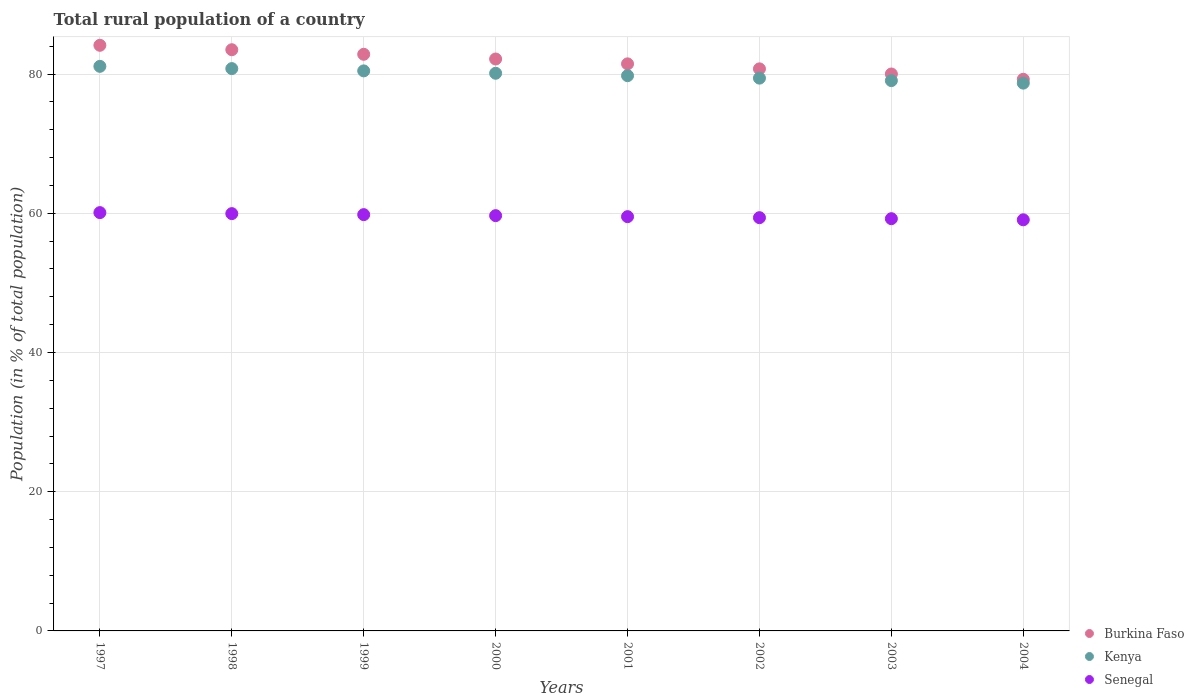How many different coloured dotlines are there?
Your answer should be compact. 3. Is the number of dotlines equal to the number of legend labels?
Provide a succinct answer. Yes. What is the rural population in Senegal in 2000?
Your answer should be compact. 59.66. Across all years, what is the maximum rural population in Burkina Faso?
Ensure brevity in your answer.  84.12. Across all years, what is the minimum rural population in Burkina Faso?
Offer a very short reply. 79.24. In which year was the rural population in Burkina Faso maximum?
Offer a very short reply. 1997. What is the total rural population in Burkina Faso in the graph?
Keep it short and to the point. 654.05. What is the difference between the rural population in Burkina Faso in 1997 and that in 2003?
Make the answer very short. 4.12. What is the difference between the rural population in Kenya in 2002 and the rural population in Senegal in 2000?
Offer a terse response. 19.75. What is the average rural population in Senegal per year?
Make the answer very short. 59.58. In the year 2002, what is the difference between the rural population in Senegal and rural population in Burkina Faso?
Offer a very short reply. -21.38. In how many years, is the rural population in Kenya greater than 20 %?
Provide a succinct answer. 8. What is the ratio of the rural population in Kenya in 1997 to that in 2004?
Offer a very short reply. 1.03. What is the difference between the highest and the second highest rural population in Kenya?
Offer a very short reply. 0.32. What is the difference between the highest and the lowest rural population in Senegal?
Ensure brevity in your answer.  1.03. In how many years, is the rural population in Senegal greater than the average rural population in Senegal taken over all years?
Make the answer very short. 4. Is the sum of the rural population in Kenya in 2000 and 2003 greater than the maximum rural population in Senegal across all years?
Keep it short and to the point. Yes. Is it the case that in every year, the sum of the rural population in Kenya and rural population in Senegal  is greater than the rural population in Burkina Faso?
Offer a terse response. Yes. Is the rural population in Burkina Faso strictly greater than the rural population in Senegal over the years?
Your answer should be very brief. Yes. Is the rural population in Senegal strictly less than the rural population in Kenya over the years?
Keep it short and to the point. Yes. How many years are there in the graph?
Your answer should be very brief. 8. What is the difference between two consecutive major ticks on the Y-axis?
Keep it short and to the point. 20. Does the graph contain any zero values?
Keep it short and to the point. No. How many legend labels are there?
Offer a very short reply. 3. How are the legend labels stacked?
Make the answer very short. Vertical. What is the title of the graph?
Ensure brevity in your answer.  Total rural population of a country. Does "Haiti" appear as one of the legend labels in the graph?
Keep it short and to the point. No. What is the label or title of the Y-axis?
Offer a terse response. Population (in % of total population). What is the Population (in % of total population) of Burkina Faso in 1997?
Give a very brief answer. 84.12. What is the Population (in % of total population) in Kenya in 1997?
Provide a succinct answer. 81.1. What is the Population (in % of total population) in Senegal in 1997?
Keep it short and to the point. 60.09. What is the Population (in % of total population) in Burkina Faso in 1998?
Give a very brief answer. 83.49. What is the Population (in % of total population) of Kenya in 1998?
Your response must be concise. 80.78. What is the Population (in % of total population) of Senegal in 1998?
Keep it short and to the point. 59.95. What is the Population (in % of total population) in Burkina Faso in 1999?
Make the answer very short. 82.83. What is the Population (in % of total population) of Kenya in 1999?
Make the answer very short. 80.45. What is the Population (in % of total population) of Senegal in 1999?
Keep it short and to the point. 59.8. What is the Population (in % of total population) of Burkina Faso in 2000?
Ensure brevity in your answer.  82.16. What is the Population (in % of total population) in Kenya in 2000?
Give a very brief answer. 80.11. What is the Population (in % of total population) of Senegal in 2000?
Give a very brief answer. 59.66. What is the Population (in % of total population) of Burkina Faso in 2001?
Provide a succinct answer. 81.46. What is the Population (in % of total population) of Kenya in 2001?
Your answer should be very brief. 79.76. What is the Population (in % of total population) in Senegal in 2001?
Your answer should be compact. 59.51. What is the Population (in % of total population) in Burkina Faso in 2002?
Keep it short and to the point. 80.74. What is the Population (in % of total population) of Kenya in 2002?
Give a very brief answer. 79.41. What is the Population (in % of total population) in Senegal in 2002?
Your response must be concise. 59.36. What is the Population (in % of total population) of Burkina Faso in 2003?
Keep it short and to the point. 80. What is the Population (in % of total population) in Kenya in 2003?
Your response must be concise. 79.05. What is the Population (in % of total population) in Senegal in 2003?
Your response must be concise. 59.22. What is the Population (in % of total population) of Burkina Faso in 2004?
Your response must be concise. 79.24. What is the Population (in % of total population) of Kenya in 2004?
Provide a succinct answer. 78.69. What is the Population (in % of total population) in Senegal in 2004?
Your answer should be compact. 59.06. Across all years, what is the maximum Population (in % of total population) in Burkina Faso?
Ensure brevity in your answer.  84.12. Across all years, what is the maximum Population (in % of total population) in Kenya?
Ensure brevity in your answer.  81.1. Across all years, what is the maximum Population (in % of total population) in Senegal?
Make the answer very short. 60.09. Across all years, what is the minimum Population (in % of total population) of Burkina Faso?
Ensure brevity in your answer.  79.24. Across all years, what is the minimum Population (in % of total population) in Kenya?
Make the answer very short. 78.69. Across all years, what is the minimum Population (in % of total population) in Senegal?
Offer a very short reply. 59.06. What is the total Population (in % of total population) of Burkina Faso in the graph?
Your answer should be compact. 654.05. What is the total Population (in % of total population) in Kenya in the graph?
Ensure brevity in your answer.  639.35. What is the total Population (in % of total population) of Senegal in the graph?
Your answer should be very brief. 476.64. What is the difference between the Population (in % of total population) in Burkina Faso in 1997 and that in 1998?
Provide a succinct answer. 0.64. What is the difference between the Population (in % of total population) of Kenya in 1997 and that in 1998?
Give a very brief answer. 0.32. What is the difference between the Population (in % of total population) of Senegal in 1997 and that in 1998?
Offer a very short reply. 0.14. What is the difference between the Population (in % of total population) of Burkina Faso in 1997 and that in 1999?
Your answer should be very brief. 1.29. What is the difference between the Population (in % of total population) in Kenya in 1997 and that in 1999?
Your answer should be very brief. 0.65. What is the difference between the Population (in % of total population) in Senegal in 1997 and that in 1999?
Provide a succinct answer. 0.29. What is the difference between the Population (in % of total population) of Burkina Faso in 1997 and that in 2000?
Your answer should be compact. 1.97. What is the difference between the Population (in % of total population) in Senegal in 1997 and that in 2000?
Make the answer very short. 0.43. What is the difference between the Population (in % of total population) of Burkina Faso in 1997 and that in 2001?
Offer a very short reply. 2.67. What is the difference between the Population (in % of total population) of Kenya in 1997 and that in 2001?
Give a very brief answer. 1.34. What is the difference between the Population (in % of total population) in Senegal in 1997 and that in 2001?
Ensure brevity in your answer.  0.58. What is the difference between the Population (in % of total population) of Burkina Faso in 1997 and that in 2002?
Your answer should be compact. 3.38. What is the difference between the Population (in % of total population) of Kenya in 1997 and that in 2002?
Offer a terse response. 1.69. What is the difference between the Population (in % of total population) of Senegal in 1997 and that in 2002?
Make the answer very short. 0.73. What is the difference between the Population (in % of total population) in Burkina Faso in 1997 and that in 2003?
Make the answer very short. 4.12. What is the difference between the Population (in % of total population) in Kenya in 1997 and that in 2003?
Keep it short and to the point. 2.05. What is the difference between the Population (in % of total population) in Senegal in 1997 and that in 2003?
Ensure brevity in your answer.  0.87. What is the difference between the Population (in % of total population) in Burkina Faso in 1997 and that in 2004?
Offer a terse response. 4.88. What is the difference between the Population (in % of total population) in Kenya in 1997 and that in 2004?
Ensure brevity in your answer.  2.41. What is the difference between the Population (in % of total population) of Senegal in 1997 and that in 2004?
Your response must be concise. 1.03. What is the difference between the Population (in % of total population) of Burkina Faso in 1998 and that in 1999?
Your response must be concise. 0.66. What is the difference between the Population (in % of total population) of Kenya in 1998 and that in 1999?
Ensure brevity in your answer.  0.33. What is the difference between the Population (in % of total population) of Senegal in 1998 and that in 1999?
Give a very brief answer. 0.14. What is the difference between the Population (in % of total population) of Burkina Faso in 1998 and that in 2000?
Your answer should be compact. 1.33. What is the difference between the Population (in % of total population) in Kenya in 1998 and that in 2000?
Offer a terse response. 0.67. What is the difference between the Population (in % of total population) of Senegal in 1998 and that in 2000?
Your answer should be very brief. 0.29. What is the difference between the Population (in % of total population) of Burkina Faso in 1998 and that in 2001?
Offer a terse response. 2.03. What is the difference between the Population (in % of total population) in Senegal in 1998 and that in 2001?
Keep it short and to the point. 0.43. What is the difference between the Population (in % of total population) in Burkina Faso in 1998 and that in 2002?
Your response must be concise. 2.75. What is the difference between the Population (in % of total population) of Kenya in 1998 and that in 2002?
Keep it short and to the point. 1.37. What is the difference between the Population (in % of total population) of Senegal in 1998 and that in 2002?
Make the answer very short. 0.58. What is the difference between the Population (in % of total population) of Burkina Faso in 1998 and that in 2003?
Your answer should be compact. 3.49. What is the difference between the Population (in % of total population) of Kenya in 1998 and that in 2003?
Your answer should be very brief. 1.73. What is the difference between the Population (in % of total population) of Senegal in 1998 and that in 2003?
Provide a succinct answer. 0.73. What is the difference between the Population (in % of total population) in Burkina Faso in 1998 and that in 2004?
Give a very brief answer. 4.25. What is the difference between the Population (in % of total population) in Kenya in 1998 and that in 2004?
Your answer should be compact. 2.09. What is the difference between the Population (in % of total population) of Senegal in 1998 and that in 2004?
Provide a short and direct response. 0.89. What is the difference between the Population (in % of total population) in Burkina Faso in 1999 and that in 2000?
Ensure brevity in your answer.  0.68. What is the difference between the Population (in % of total population) in Kenya in 1999 and that in 2000?
Your answer should be very brief. 0.34. What is the difference between the Population (in % of total population) of Senegal in 1999 and that in 2000?
Your response must be concise. 0.14. What is the difference between the Population (in % of total population) in Burkina Faso in 1999 and that in 2001?
Keep it short and to the point. 1.37. What is the difference between the Population (in % of total population) of Kenya in 1999 and that in 2001?
Your answer should be compact. 0.69. What is the difference between the Population (in % of total population) of Senegal in 1999 and that in 2001?
Your answer should be compact. 0.29. What is the difference between the Population (in % of total population) in Burkina Faso in 1999 and that in 2002?
Give a very brief answer. 2.09. What is the difference between the Population (in % of total population) of Kenya in 1999 and that in 2002?
Your answer should be very brief. 1.04. What is the difference between the Population (in % of total population) in Senegal in 1999 and that in 2002?
Give a very brief answer. 0.44. What is the difference between the Population (in % of total population) in Burkina Faso in 1999 and that in 2003?
Provide a succinct answer. 2.83. What is the difference between the Population (in % of total population) of Kenya in 1999 and that in 2003?
Offer a terse response. 1.4. What is the difference between the Population (in % of total population) in Senegal in 1999 and that in 2003?
Keep it short and to the point. 0.58. What is the difference between the Population (in % of total population) in Burkina Faso in 1999 and that in 2004?
Make the answer very short. 3.59. What is the difference between the Population (in % of total population) in Kenya in 1999 and that in 2004?
Offer a terse response. 1.76. What is the difference between the Population (in % of total population) in Senegal in 1999 and that in 2004?
Provide a succinct answer. 0.74. What is the difference between the Population (in % of total population) of Burkina Faso in 2000 and that in 2001?
Your answer should be compact. 0.7. What is the difference between the Population (in % of total population) of Kenya in 2000 and that in 2001?
Ensure brevity in your answer.  0.35. What is the difference between the Population (in % of total population) of Senegal in 2000 and that in 2001?
Offer a terse response. 0.14. What is the difference between the Population (in % of total population) in Burkina Faso in 2000 and that in 2002?
Provide a succinct answer. 1.41. What is the difference between the Population (in % of total population) in Kenya in 2000 and that in 2002?
Keep it short and to the point. 0.7. What is the difference between the Population (in % of total population) of Senegal in 2000 and that in 2002?
Ensure brevity in your answer.  0.29. What is the difference between the Population (in % of total population) of Burkina Faso in 2000 and that in 2003?
Provide a succinct answer. 2.15. What is the difference between the Population (in % of total population) of Kenya in 2000 and that in 2003?
Give a very brief answer. 1.06. What is the difference between the Population (in % of total population) of Senegal in 2000 and that in 2003?
Make the answer very short. 0.44. What is the difference between the Population (in % of total population) in Burkina Faso in 2000 and that in 2004?
Your response must be concise. 2.91. What is the difference between the Population (in % of total population) of Kenya in 2000 and that in 2004?
Offer a terse response. 1.42. What is the difference between the Population (in % of total population) of Senegal in 2000 and that in 2004?
Ensure brevity in your answer.  0.6. What is the difference between the Population (in % of total population) in Burkina Faso in 2001 and that in 2002?
Your answer should be very brief. 0.72. What is the difference between the Population (in % of total population) of Kenya in 2001 and that in 2002?
Offer a terse response. 0.35. What is the difference between the Population (in % of total population) in Senegal in 2001 and that in 2002?
Offer a very short reply. 0.15. What is the difference between the Population (in % of total population) of Burkina Faso in 2001 and that in 2003?
Make the answer very short. 1.46. What is the difference between the Population (in % of total population) of Kenya in 2001 and that in 2003?
Ensure brevity in your answer.  0.71. What is the difference between the Population (in % of total population) of Senegal in 2001 and that in 2003?
Offer a terse response. 0.29. What is the difference between the Population (in % of total population) of Burkina Faso in 2001 and that in 2004?
Provide a succinct answer. 2.22. What is the difference between the Population (in % of total population) of Kenya in 2001 and that in 2004?
Your answer should be compact. 1.07. What is the difference between the Population (in % of total population) in Senegal in 2001 and that in 2004?
Provide a short and direct response. 0.45. What is the difference between the Population (in % of total population) in Burkina Faso in 2002 and that in 2003?
Give a very brief answer. 0.74. What is the difference between the Population (in % of total population) in Kenya in 2002 and that in 2003?
Your response must be concise. 0.36. What is the difference between the Population (in % of total population) in Senegal in 2002 and that in 2003?
Your answer should be very brief. 0.15. What is the difference between the Population (in % of total population) in Burkina Faso in 2002 and that in 2004?
Your answer should be very brief. 1.5. What is the difference between the Population (in % of total population) of Kenya in 2002 and that in 2004?
Your response must be concise. 0.72. What is the difference between the Population (in % of total population) of Senegal in 2002 and that in 2004?
Give a very brief answer. 0.31. What is the difference between the Population (in % of total population) of Burkina Faso in 2003 and that in 2004?
Your response must be concise. 0.76. What is the difference between the Population (in % of total population) of Kenya in 2003 and that in 2004?
Offer a terse response. 0.36. What is the difference between the Population (in % of total population) of Senegal in 2003 and that in 2004?
Your answer should be compact. 0.16. What is the difference between the Population (in % of total population) in Burkina Faso in 1997 and the Population (in % of total population) in Kenya in 1998?
Offer a very short reply. 3.35. What is the difference between the Population (in % of total population) in Burkina Faso in 1997 and the Population (in % of total population) in Senegal in 1998?
Give a very brief answer. 24.18. What is the difference between the Population (in % of total population) in Kenya in 1997 and the Population (in % of total population) in Senegal in 1998?
Ensure brevity in your answer.  21.16. What is the difference between the Population (in % of total population) of Burkina Faso in 1997 and the Population (in % of total population) of Kenya in 1999?
Give a very brief answer. 3.67. What is the difference between the Population (in % of total population) of Burkina Faso in 1997 and the Population (in % of total population) of Senegal in 1999?
Offer a terse response. 24.32. What is the difference between the Population (in % of total population) in Kenya in 1997 and the Population (in % of total population) in Senegal in 1999?
Offer a terse response. 21.3. What is the difference between the Population (in % of total population) in Burkina Faso in 1997 and the Population (in % of total population) in Kenya in 2000?
Provide a succinct answer. 4.02. What is the difference between the Population (in % of total population) of Burkina Faso in 1997 and the Population (in % of total population) of Senegal in 2000?
Your response must be concise. 24.47. What is the difference between the Population (in % of total population) of Kenya in 1997 and the Population (in % of total population) of Senegal in 2000?
Ensure brevity in your answer.  21.45. What is the difference between the Population (in % of total population) in Burkina Faso in 1997 and the Population (in % of total population) in Kenya in 2001?
Give a very brief answer. 4.36. What is the difference between the Population (in % of total population) of Burkina Faso in 1997 and the Population (in % of total population) of Senegal in 2001?
Your response must be concise. 24.61. What is the difference between the Population (in % of total population) of Kenya in 1997 and the Population (in % of total population) of Senegal in 2001?
Your response must be concise. 21.59. What is the difference between the Population (in % of total population) in Burkina Faso in 1997 and the Population (in % of total population) in Kenya in 2002?
Your answer should be compact. 4.72. What is the difference between the Population (in % of total population) of Burkina Faso in 1997 and the Population (in % of total population) of Senegal in 2002?
Your answer should be compact. 24.76. What is the difference between the Population (in % of total population) of Kenya in 1997 and the Population (in % of total population) of Senegal in 2002?
Your answer should be compact. 21.74. What is the difference between the Population (in % of total population) of Burkina Faso in 1997 and the Population (in % of total population) of Kenya in 2003?
Make the answer very short. 5.07. What is the difference between the Population (in % of total population) in Burkina Faso in 1997 and the Population (in % of total population) in Senegal in 2003?
Your answer should be very brief. 24.91. What is the difference between the Population (in % of total population) of Kenya in 1997 and the Population (in % of total population) of Senegal in 2003?
Provide a short and direct response. 21.88. What is the difference between the Population (in % of total population) in Burkina Faso in 1997 and the Population (in % of total population) in Kenya in 2004?
Ensure brevity in your answer.  5.43. What is the difference between the Population (in % of total population) in Burkina Faso in 1997 and the Population (in % of total population) in Senegal in 2004?
Provide a short and direct response. 25.07. What is the difference between the Population (in % of total population) in Kenya in 1997 and the Population (in % of total population) in Senegal in 2004?
Your response must be concise. 22.05. What is the difference between the Population (in % of total population) of Burkina Faso in 1998 and the Population (in % of total population) of Kenya in 1999?
Keep it short and to the point. 3.04. What is the difference between the Population (in % of total population) in Burkina Faso in 1998 and the Population (in % of total population) in Senegal in 1999?
Provide a succinct answer. 23.69. What is the difference between the Population (in % of total population) in Kenya in 1998 and the Population (in % of total population) in Senegal in 1999?
Make the answer very short. 20.98. What is the difference between the Population (in % of total population) in Burkina Faso in 1998 and the Population (in % of total population) in Kenya in 2000?
Your answer should be very brief. 3.38. What is the difference between the Population (in % of total population) of Burkina Faso in 1998 and the Population (in % of total population) of Senegal in 2000?
Your response must be concise. 23.84. What is the difference between the Population (in % of total population) of Kenya in 1998 and the Population (in % of total population) of Senegal in 2000?
Keep it short and to the point. 21.12. What is the difference between the Population (in % of total population) in Burkina Faso in 1998 and the Population (in % of total population) in Kenya in 2001?
Your answer should be compact. 3.73. What is the difference between the Population (in % of total population) in Burkina Faso in 1998 and the Population (in % of total population) in Senegal in 2001?
Keep it short and to the point. 23.98. What is the difference between the Population (in % of total population) in Kenya in 1998 and the Population (in % of total population) in Senegal in 2001?
Make the answer very short. 21.27. What is the difference between the Population (in % of total population) in Burkina Faso in 1998 and the Population (in % of total population) in Kenya in 2002?
Ensure brevity in your answer.  4.08. What is the difference between the Population (in % of total population) of Burkina Faso in 1998 and the Population (in % of total population) of Senegal in 2002?
Your answer should be compact. 24.13. What is the difference between the Population (in % of total population) of Kenya in 1998 and the Population (in % of total population) of Senegal in 2002?
Your answer should be very brief. 21.41. What is the difference between the Population (in % of total population) in Burkina Faso in 1998 and the Population (in % of total population) in Kenya in 2003?
Offer a terse response. 4.44. What is the difference between the Population (in % of total population) in Burkina Faso in 1998 and the Population (in % of total population) in Senegal in 2003?
Provide a short and direct response. 24.27. What is the difference between the Population (in % of total population) in Kenya in 1998 and the Population (in % of total population) in Senegal in 2003?
Offer a very short reply. 21.56. What is the difference between the Population (in % of total population) of Burkina Faso in 1998 and the Population (in % of total population) of Senegal in 2004?
Keep it short and to the point. 24.43. What is the difference between the Population (in % of total population) of Kenya in 1998 and the Population (in % of total population) of Senegal in 2004?
Keep it short and to the point. 21.72. What is the difference between the Population (in % of total population) in Burkina Faso in 1999 and the Population (in % of total population) in Kenya in 2000?
Ensure brevity in your answer.  2.73. What is the difference between the Population (in % of total population) in Burkina Faso in 1999 and the Population (in % of total population) in Senegal in 2000?
Offer a very short reply. 23.18. What is the difference between the Population (in % of total population) of Kenya in 1999 and the Population (in % of total population) of Senegal in 2000?
Provide a short and direct response. 20.8. What is the difference between the Population (in % of total population) of Burkina Faso in 1999 and the Population (in % of total population) of Kenya in 2001?
Make the answer very short. 3.07. What is the difference between the Population (in % of total population) of Burkina Faso in 1999 and the Population (in % of total population) of Senegal in 2001?
Provide a short and direct response. 23.32. What is the difference between the Population (in % of total population) of Kenya in 1999 and the Population (in % of total population) of Senegal in 2001?
Give a very brief answer. 20.94. What is the difference between the Population (in % of total population) in Burkina Faso in 1999 and the Population (in % of total population) in Kenya in 2002?
Your response must be concise. 3.42. What is the difference between the Population (in % of total population) in Burkina Faso in 1999 and the Population (in % of total population) in Senegal in 2002?
Your answer should be compact. 23.47. What is the difference between the Population (in % of total population) in Kenya in 1999 and the Population (in % of total population) in Senegal in 2002?
Your answer should be compact. 21.09. What is the difference between the Population (in % of total population) of Burkina Faso in 1999 and the Population (in % of total population) of Kenya in 2003?
Keep it short and to the point. 3.78. What is the difference between the Population (in % of total population) of Burkina Faso in 1999 and the Population (in % of total population) of Senegal in 2003?
Give a very brief answer. 23.62. What is the difference between the Population (in % of total population) of Kenya in 1999 and the Population (in % of total population) of Senegal in 2003?
Your answer should be compact. 21.23. What is the difference between the Population (in % of total population) in Burkina Faso in 1999 and the Population (in % of total population) in Kenya in 2004?
Make the answer very short. 4.14. What is the difference between the Population (in % of total population) of Burkina Faso in 1999 and the Population (in % of total population) of Senegal in 2004?
Give a very brief answer. 23.78. What is the difference between the Population (in % of total population) of Kenya in 1999 and the Population (in % of total population) of Senegal in 2004?
Provide a short and direct response. 21.39. What is the difference between the Population (in % of total population) in Burkina Faso in 2000 and the Population (in % of total population) in Kenya in 2001?
Provide a short and direct response. 2.4. What is the difference between the Population (in % of total population) of Burkina Faso in 2000 and the Population (in % of total population) of Senegal in 2001?
Provide a short and direct response. 22.65. What is the difference between the Population (in % of total population) of Kenya in 2000 and the Population (in % of total population) of Senegal in 2001?
Ensure brevity in your answer.  20.6. What is the difference between the Population (in % of total population) of Burkina Faso in 2000 and the Population (in % of total population) of Kenya in 2002?
Offer a very short reply. 2.75. What is the difference between the Population (in % of total population) in Burkina Faso in 2000 and the Population (in % of total population) in Senegal in 2002?
Provide a succinct answer. 22.79. What is the difference between the Population (in % of total population) of Kenya in 2000 and the Population (in % of total population) of Senegal in 2002?
Provide a succinct answer. 20.74. What is the difference between the Population (in % of total population) in Burkina Faso in 2000 and the Population (in % of total population) in Kenya in 2003?
Ensure brevity in your answer.  3.1. What is the difference between the Population (in % of total population) in Burkina Faso in 2000 and the Population (in % of total population) in Senegal in 2003?
Offer a very short reply. 22.94. What is the difference between the Population (in % of total population) in Kenya in 2000 and the Population (in % of total population) in Senegal in 2003?
Provide a succinct answer. 20.89. What is the difference between the Population (in % of total population) of Burkina Faso in 2000 and the Population (in % of total population) of Kenya in 2004?
Your response must be concise. 3.47. What is the difference between the Population (in % of total population) of Burkina Faso in 2000 and the Population (in % of total population) of Senegal in 2004?
Give a very brief answer. 23.1. What is the difference between the Population (in % of total population) of Kenya in 2000 and the Population (in % of total population) of Senegal in 2004?
Your answer should be very brief. 21.05. What is the difference between the Population (in % of total population) in Burkina Faso in 2001 and the Population (in % of total population) in Kenya in 2002?
Give a very brief answer. 2.05. What is the difference between the Population (in % of total population) of Burkina Faso in 2001 and the Population (in % of total population) of Senegal in 2002?
Give a very brief answer. 22.1. What is the difference between the Population (in % of total population) of Kenya in 2001 and the Population (in % of total population) of Senegal in 2002?
Your response must be concise. 20.4. What is the difference between the Population (in % of total population) in Burkina Faso in 2001 and the Population (in % of total population) in Kenya in 2003?
Your answer should be very brief. 2.41. What is the difference between the Population (in % of total population) of Burkina Faso in 2001 and the Population (in % of total population) of Senegal in 2003?
Give a very brief answer. 22.24. What is the difference between the Population (in % of total population) of Kenya in 2001 and the Population (in % of total population) of Senegal in 2003?
Provide a short and direct response. 20.54. What is the difference between the Population (in % of total population) of Burkina Faso in 2001 and the Population (in % of total population) of Kenya in 2004?
Ensure brevity in your answer.  2.77. What is the difference between the Population (in % of total population) of Burkina Faso in 2001 and the Population (in % of total population) of Senegal in 2004?
Give a very brief answer. 22.4. What is the difference between the Population (in % of total population) in Kenya in 2001 and the Population (in % of total population) in Senegal in 2004?
Your answer should be very brief. 20.7. What is the difference between the Population (in % of total population) of Burkina Faso in 2002 and the Population (in % of total population) of Kenya in 2003?
Offer a very short reply. 1.69. What is the difference between the Population (in % of total population) of Burkina Faso in 2002 and the Population (in % of total population) of Senegal in 2003?
Your answer should be very brief. 21.52. What is the difference between the Population (in % of total population) in Kenya in 2002 and the Population (in % of total population) in Senegal in 2003?
Provide a succinct answer. 20.19. What is the difference between the Population (in % of total population) in Burkina Faso in 2002 and the Population (in % of total population) in Kenya in 2004?
Ensure brevity in your answer.  2.05. What is the difference between the Population (in % of total population) in Burkina Faso in 2002 and the Population (in % of total population) in Senegal in 2004?
Your answer should be very brief. 21.68. What is the difference between the Population (in % of total population) of Kenya in 2002 and the Population (in % of total population) of Senegal in 2004?
Offer a very short reply. 20.35. What is the difference between the Population (in % of total population) in Burkina Faso in 2003 and the Population (in % of total population) in Kenya in 2004?
Offer a very short reply. 1.31. What is the difference between the Population (in % of total population) in Burkina Faso in 2003 and the Population (in % of total population) in Senegal in 2004?
Make the answer very short. 20.95. What is the difference between the Population (in % of total population) in Kenya in 2003 and the Population (in % of total population) in Senegal in 2004?
Provide a short and direct response. 20. What is the average Population (in % of total population) in Burkina Faso per year?
Your answer should be very brief. 81.76. What is the average Population (in % of total population) of Kenya per year?
Give a very brief answer. 79.92. What is the average Population (in % of total population) in Senegal per year?
Give a very brief answer. 59.58. In the year 1997, what is the difference between the Population (in % of total population) in Burkina Faso and Population (in % of total population) in Kenya?
Your answer should be very brief. 3.02. In the year 1997, what is the difference between the Population (in % of total population) of Burkina Faso and Population (in % of total population) of Senegal?
Your answer should be compact. 24.04. In the year 1997, what is the difference between the Population (in % of total population) in Kenya and Population (in % of total population) in Senegal?
Give a very brief answer. 21.01. In the year 1998, what is the difference between the Population (in % of total population) of Burkina Faso and Population (in % of total population) of Kenya?
Your answer should be compact. 2.71. In the year 1998, what is the difference between the Population (in % of total population) of Burkina Faso and Population (in % of total population) of Senegal?
Ensure brevity in your answer.  23.55. In the year 1998, what is the difference between the Population (in % of total population) of Kenya and Population (in % of total population) of Senegal?
Ensure brevity in your answer.  20.83. In the year 1999, what is the difference between the Population (in % of total population) in Burkina Faso and Population (in % of total population) in Kenya?
Offer a very short reply. 2.38. In the year 1999, what is the difference between the Population (in % of total population) in Burkina Faso and Population (in % of total population) in Senegal?
Offer a very short reply. 23.03. In the year 1999, what is the difference between the Population (in % of total population) of Kenya and Population (in % of total population) of Senegal?
Provide a short and direct response. 20.65. In the year 2000, what is the difference between the Population (in % of total population) of Burkina Faso and Population (in % of total population) of Kenya?
Offer a terse response. 2.05. In the year 2000, what is the difference between the Population (in % of total population) of Burkina Faso and Population (in % of total population) of Senegal?
Offer a very short reply. 22.5. In the year 2000, what is the difference between the Population (in % of total population) of Kenya and Population (in % of total population) of Senegal?
Ensure brevity in your answer.  20.45. In the year 2001, what is the difference between the Population (in % of total population) in Burkina Faso and Population (in % of total population) in Kenya?
Ensure brevity in your answer.  1.7. In the year 2001, what is the difference between the Population (in % of total population) of Burkina Faso and Population (in % of total population) of Senegal?
Offer a terse response. 21.95. In the year 2001, what is the difference between the Population (in % of total population) of Kenya and Population (in % of total population) of Senegal?
Your answer should be very brief. 20.25. In the year 2002, what is the difference between the Population (in % of total population) in Burkina Faso and Population (in % of total population) in Kenya?
Keep it short and to the point. 1.33. In the year 2002, what is the difference between the Population (in % of total population) of Burkina Faso and Population (in % of total population) of Senegal?
Provide a short and direct response. 21.38. In the year 2002, what is the difference between the Population (in % of total population) of Kenya and Population (in % of total population) of Senegal?
Your answer should be very brief. 20.05. In the year 2003, what is the difference between the Population (in % of total population) in Burkina Faso and Population (in % of total population) in Kenya?
Keep it short and to the point. 0.95. In the year 2003, what is the difference between the Population (in % of total population) in Burkina Faso and Population (in % of total population) in Senegal?
Your answer should be very brief. 20.79. In the year 2003, what is the difference between the Population (in % of total population) in Kenya and Population (in % of total population) in Senegal?
Ensure brevity in your answer.  19.83. In the year 2004, what is the difference between the Population (in % of total population) in Burkina Faso and Population (in % of total population) in Kenya?
Make the answer very short. 0.55. In the year 2004, what is the difference between the Population (in % of total population) of Burkina Faso and Population (in % of total population) of Senegal?
Offer a terse response. 20.19. In the year 2004, what is the difference between the Population (in % of total population) in Kenya and Population (in % of total population) in Senegal?
Make the answer very short. 19.63. What is the ratio of the Population (in % of total population) of Burkina Faso in 1997 to that in 1998?
Provide a short and direct response. 1.01. What is the ratio of the Population (in % of total population) in Kenya in 1997 to that in 1998?
Provide a succinct answer. 1. What is the ratio of the Population (in % of total population) of Senegal in 1997 to that in 1998?
Make the answer very short. 1. What is the ratio of the Population (in % of total population) in Burkina Faso in 1997 to that in 1999?
Offer a very short reply. 1.02. What is the ratio of the Population (in % of total population) in Kenya in 1997 to that in 1999?
Your answer should be very brief. 1.01. What is the ratio of the Population (in % of total population) in Senegal in 1997 to that in 1999?
Your answer should be very brief. 1. What is the ratio of the Population (in % of total population) of Burkina Faso in 1997 to that in 2000?
Give a very brief answer. 1.02. What is the ratio of the Population (in % of total population) of Kenya in 1997 to that in 2000?
Offer a terse response. 1.01. What is the ratio of the Population (in % of total population) of Senegal in 1997 to that in 2000?
Keep it short and to the point. 1.01. What is the ratio of the Population (in % of total population) of Burkina Faso in 1997 to that in 2001?
Provide a succinct answer. 1.03. What is the ratio of the Population (in % of total population) in Kenya in 1997 to that in 2001?
Make the answer very short. 1.02. What is the ratio of the Population (in % of total population) in Senegal in 1997 to that in 2001?
Your response must be concise. 1.01. What is the ratio of the Population (in % of total population) of Burkina Faso in 1997 to that in 2002?
Your response must be concise. 1.04. What is the ratio of the Population (in % of total population) of Kenya in 1997 to that in 2002?
Make the answer very short. 1.02. What is the ratio of the Population (in % of total population) of Senegal in 1997 to that in 2002?
Offer a very short reply. 1.01. What is the ratio of the Population (in % of total population) in Burkina Faso in 1997 to that in 2003?
Offer a terse response. 1.05. What is the ratio of the Population (in % of total population) of Kenya in 1997 to that in 2003?
Ensure brevity in your answer.  1.03. What is the ratio of the Population (in % of total population) in Senegal in 1997 to that in 2003?
Ensure brevity in your answer.  1.01. What is the ratio of the Population (in % of total population) in Burkina Faso in 1997 to that in 2004?
Offer a terse response. 1.06. What is the ratio of the Population (in % of total population) in Kenya in 1997 to that in 2004?
Keep it short and to the point. 1.03. What is the ratio of the Population (in % of total population) of Senegal in 1997 to that in 2004?
Provide a short and direct response. 1.02. What is the ratio of the Population (in % of total population) in Burkina Faso in 1998 to that in 1999?
Ensure brevity in your answer.  1.01. What is the ratio of the Population (in % of total population) of Burkina Faso in 1998 to that in 2000?
Provide a short and direct response. 1.02. What is the ratio of the Population (in % of total population) in Kenya in 1998 to that in 2000?
Your answer should be very brief. 1.01. What is the ratio of the Population (in % of total population) of Burkina Faso in 1998 to that in 2001?
Your answer should be very brief. 1.02. What is the ratio of the Population (in % of total population) in Kenya in 1998 to that in 2001?
Make the answer very short. 1.01. What is the ratio of the Population (in % of total population) in Senegal in 1998 to that in 2001?
Give a very brief answer. 1.01. What is the ratio of the Population (in % of total population) of Burkina Faso in 1998 to that in 2002?
Give a very brief answer. 1.03. What is the ratio of the Population (in % of total population) in Kenya in 1998 to that in 2002?
Offer a very short reply. 1.02. What is the ratio of the Population (in % of total population) in Senegal in 1998 to that in 2002?
Provide a succinct answer. 1.01. What is the ratio of the Population (in % of total population) of Burkina Faso in 1998 to that in 2003?
Make the answer very short. 1.04. What is the ratio of the Population (in % of total population) in Kenya in 1998 to that in 2003?
Your answer should be compact. 1.02. What is the ratio of the Population (in % of total population) in Senegal in 1998 to that in 2003?
Your answer should be compact. 1.01. What is the ratio of the Population (in % of total population) of Burkina Faso in 1998 to that in 2004?
Your answer should be compact. 1.05. What is the ratio of the Population (in % of total population) in Kenya in 1998 to that in 2004?
Offer a very short reply. 1.03. What is the ratio of the Population (in % of total population) in Burkina Faso in 1999 to that in 2000?
Make the answer very short. 1.01. What is the ratio of the Population (in % of total population) in Senegal in 1999 to that in 2000?
Ensure brevity in your answer.  1. What is the ratio of the Population (in % of total population) in Burkina Faso in 1999 to that in 2001?
Offer a very short reply. 1.02. What is the ratio of the Population (in % of total population) of Kenya in 1999 to that in 2001?
Keep it short and to the point. 1.01. What is the ratio of the Population (in % of total population) of Senegal in 1999 to that in 2001?
Your answer should be compact. 1. What is the ratio of the Population (in % of total population) in Burkina Faso in 1999 to that in 2002?
Offer a very short reply. 1.03. What is the ratio of the Population (in % of total population) of Kenya in 1999 to that in 2002?
Provide a short and direct response. 1.01. What is the ratio of the Population (in % of total population) in Senegal in 1999 to that in 2002?
Keep it short and to the point. 1.01. What is the ratio of the Population (in % of total population) of Burkina Faso in 1999 to that in 2003?
Your response must be concise. 1.04. What is the ratio of the Population (in % of total population) in Kenya in 1999 to that in 2003?
Provide a succinct answer. 1.02. What is the ratio of the Population (in % of total population) in Senegal in 1999 to that in 2003?
Ensure brevity in your answer.  1.01. What is the ratio of the Population (in % of total population) of Burkina Faso in 1999 to that in 2004?
Provide a short and direct response. 1.05. What is the ratio of the Population (in % of total population) of Kenya in 1999 to that in 2004?
Your response must be concise. 1.02. What is the ratio of the Population (in % of total population) in Senegal in 1999 to that in 2004?
Keep it short and to the point. 1.01. What is the ratio of the Population (in % of total population) in Burkina Faso in 2000 to that in 2001?
Your answer should be very brief. 1.01. What is the ratio of the Population (in % of total population) in Burkina Faso in 2000 to that in 2002?
Give a very brief answer. 1.02. What is the ratio of the Population (in % of total population) in Kenya in 2000 to that in 2002?
Give a very brief answer. 1.01. What is the ratio of the Population (in % of total population) of Senegal in 2000 to that in 2002?
Keep it short and to the point. 1. What is the ratio of the Population (in % of total population) in Burkina Faso in 2000 to that in 2003?
Ensure brevity in your answer.  1.03. What is the ratio of the Population (in % of total population) in Kenya in 2000 to that in 2003?
Your response must be concise. 1.01. What is the ratio of the Population (in % of total population) in Senegal in 2000 to that in 2003?
Offer a very short reply. 1.01. What is the ratio of the Population (in % of total population) of Burkina Faso in 2000 to that in 2004?
Your response must be concise. 1.04. What is the ratio of the Population (in % of total population) of Burkina Faso in 2001 to that in 2002?
Provide a succinct answer. 1.01. What is the ratio of the Population (in % of total population) in Kenya in 2001 to that in 2002?
Your answer should be very brief. 1. What is the ratio of the Population (in % of total population) in Burkina Faso in 2001 to that in 2003?
Offer a terse response. 1.02. What is the ratio of the Population (in % of total population) of Kenya in 2001 to that in 2003?
Provide a succinct answer. 1.01. What is the ratio of the Population (in % of total population) in Senegal in 2001 to that in 2003?
Provide a succinct answer. 1. What is the ratio of the Population (in % of total population) in Burkina Faso in 2001 to that in 2004?
Ensure brevity in your answer.  1.03. What is the ratio of the Population (in % of total population) of Kenya in 2001 to that in 2004?
Your answer should be compact. 1.01. What is the ratio of the Population (in % of total population) of Senegal in 2001 to that in 2004?
Provide a succinct answer. 1.01. What is the ratio of the Population (in % of total population) in Burkina Faso in 2002 to that in 2003?
Ensure brevity in your answer.  1.01. What is the ratio of the Population (in % of total population) of Kenya in 2002 to that in 2003?
Give a very brief answer. 1. What is the ratio of the Population (in % of total population) of Senegal in 2002 to that in 2003?
Offer a very short reply. 1. What is the ratio of the Population (in % of total population) in Burkina Faso in 2002 to that in 2004?
Give a very brief answer. 1.02. What is the ratio of the Population (in % of total population) in Kenya in 2002 to that in 2004?
Your response must be concise. 1.01. What is the ratio of the Population (in % of total population) of Senegal in 2002 to that in 2004?
Ensure brevity in your answer.  1.01. What is the ratio of the Population (in % of total population) of Burkina Faso in 2003 to that in 2004?
Give a very brief answer. 1.01. What is the ratio of the Population (in % of total population) of Kenya in 2003 to that in 2004?
Provide a short and direct response. 1. What is the difference between the highest and the second highest Population (in % of total population) in Burkina Faso?
Provide a succinct answer. 0.64. What is the difference between the highest and the second highest Population (in % of total population) of Kenya?
Provide a succinct answer. 0.32. What is the difference between the highest and the second highest Population (in % of total population) of Senegal?
Your response must be concise. 0.14. What is the difference between the highest and the lowest Population (in % of total population) in Burkina Faso?
Your answer should be very brief. 4.88. What is the difference between the highest and the lowest Population (in % of total population) of Kenya?
Ensure brevity in your answer.  2.41. What is the difference between the highest and the lowest Population (in % of total population) of Senegal?
Provide a short and direct response. 1.03. 